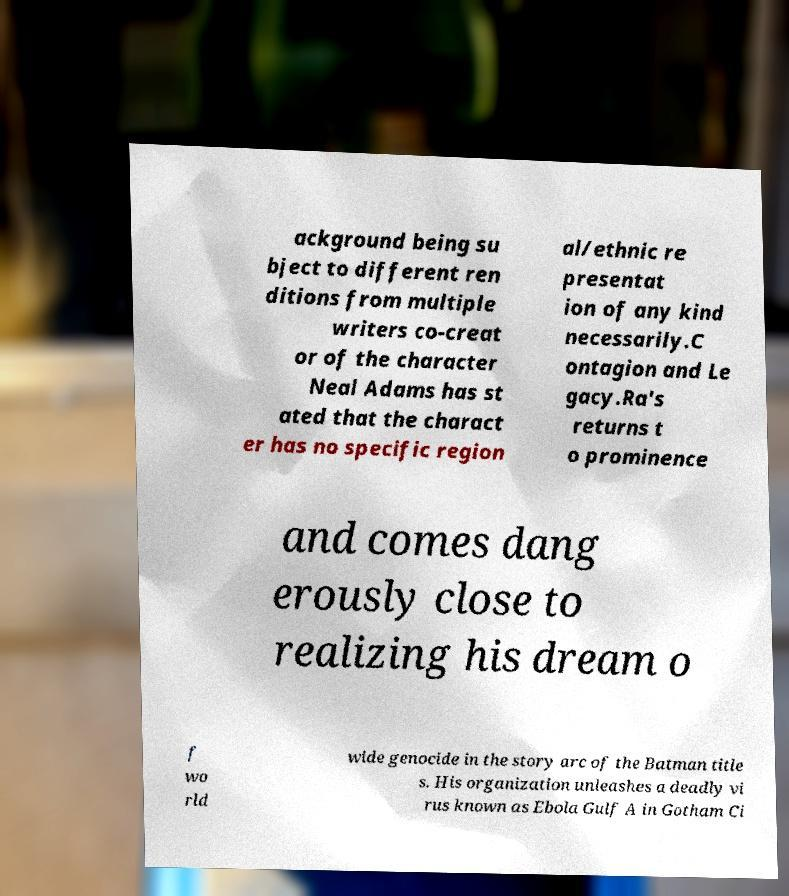Could you extract and type out the text from this image? ackground being su bject to different ren ditions from multiple writers co-creat or of the character Neal Adams has st ated that the charact er has no specific region al/ethnic re presentat ion of any kind necessarily.C ontagion and Le gacy.Ra's returns t o prominence and comes dang erously close to realizing his dream o f wo rld wide genocide in the story arc of the Batman title s. His organization unleashes a deadly vi rus known as Ebola Gulf A in Gotham Ci 